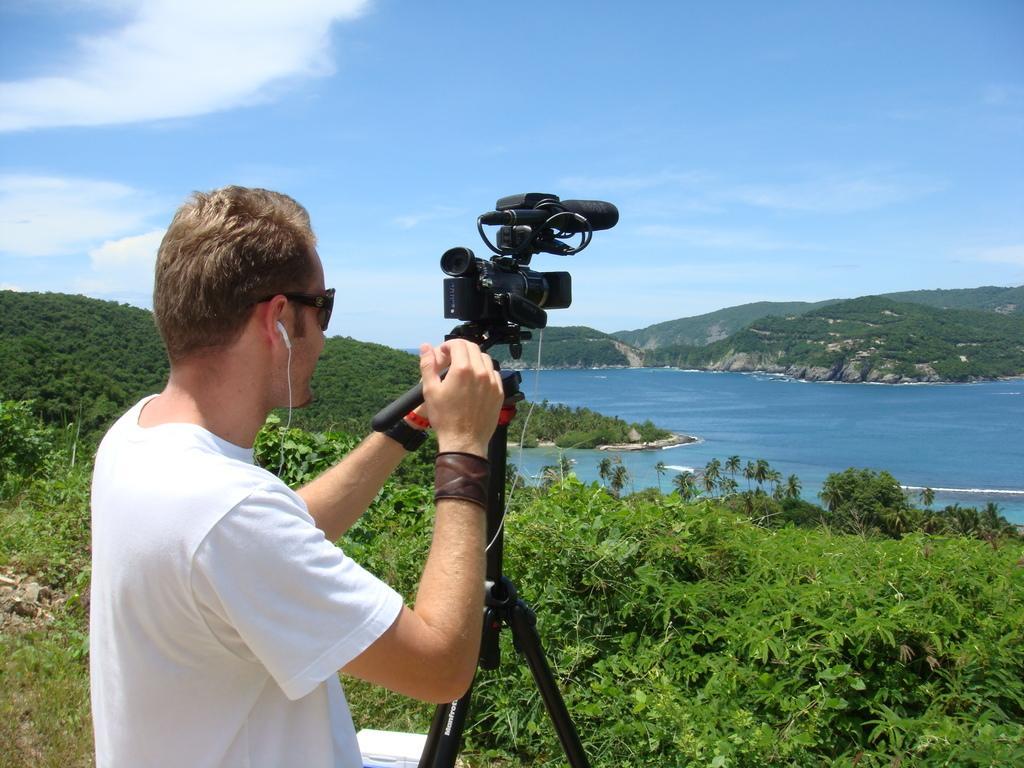Could you give a brief overview of what you see in this image? In this image I can see there is a man standing and he is holding a video camera attached to the stand and there are a few plants and there is a mountain in the backdrop, there are few trees on the mountain and there is a river and the sky is clear. 